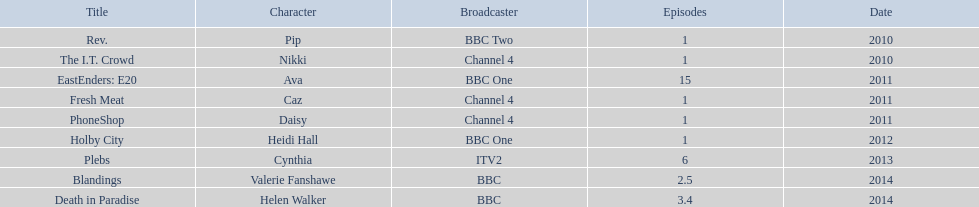Which characters appeared in multiple episodes? Ava, Cynthia, Valerie Fanshawe, Helen Walker. Which of these didn't occur in 2014? Ava, Cynthia. Which one of those wasn't broadcasted on a bbc channel? Cynthia. 